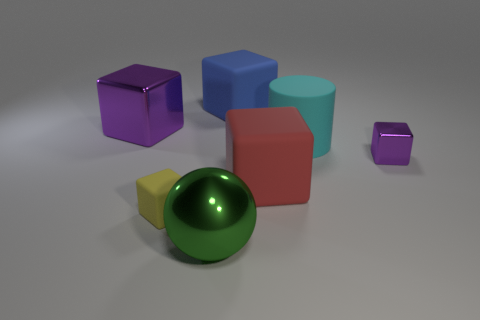Subtract all green blocks. Subtract all yellow cylinders. How many blocks are left? 5 Add 2 matte things. How many objects exist? 9 Subtract all balls. How many objects are left? 6 Add 4 green shiny objects. How many green shiny objects exist? 5 Subtract 0 gray blocks. How many objects are left? 7 Subtract all tiny yellow cubes. Subtract all small things. How many objects are left? 4 Add 5 tiny purple metal cubes. How many tiny purple metal cubes are left? 6 